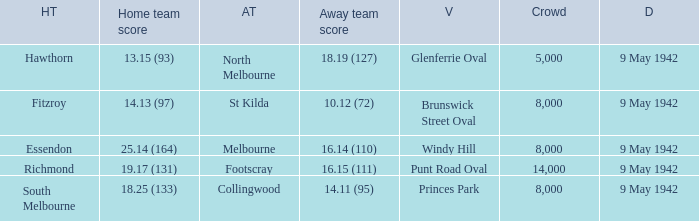How large was the crowd with a home team score of 18.25 (133)? 8000.0. 